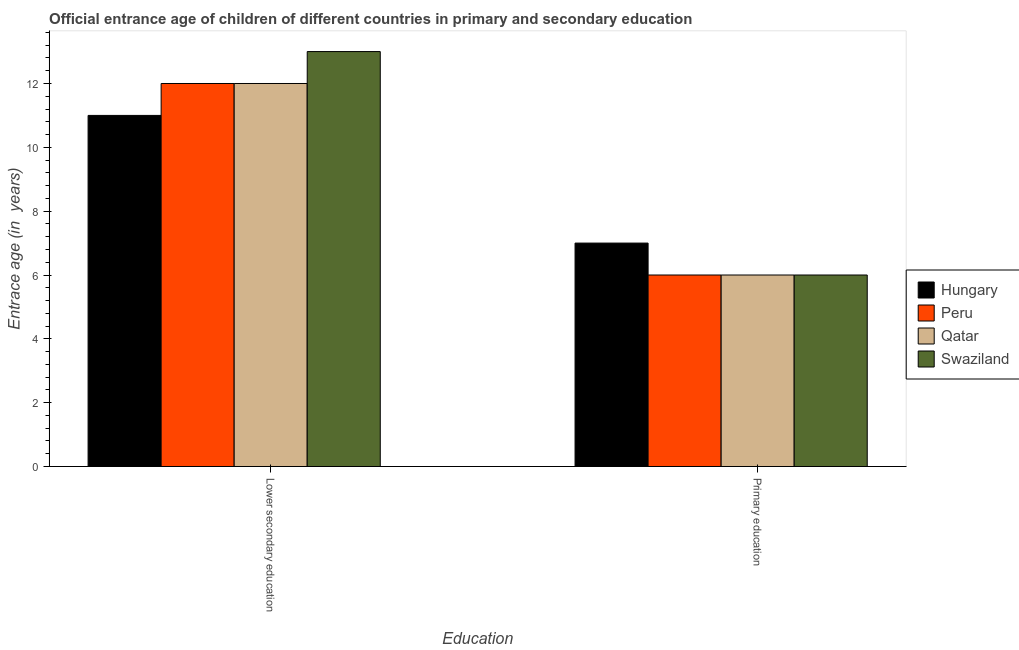How many bars are there on the 1st tick from the left?
Your response must be concise. 4. What is the label of the 2nd group of bars from the left?
Keep it short and to the point. Primary education. Across all countries, what is the maximum entrance age of children in lower secondary education?
Provide a succinct answer. 13. Across all countries, what is the minimum entrance age of children in lower secondary education?
Ensure brevity in your answer.  11. In which country was the entrance age of children in lower secondary education maximum?
Ensure brevity in your answer.  Swaziland. In which country was the entrance age of children in lower secondary education minimum?
Your answer should be compact. Hungary. What is the total entrance age of children in lower secondary education in the graph?
Provide a succinct answer. 48. What is the difference between the entrance age of children in lower secondary education in Qatar and the entrance age of chiildren in primary education in Peru?
Your answer should be compact. 6. What is the average entrance age of children in lower secondary education per country?
Make the answer very short. 12. What is the difference between the entrance age of chiildren in primary education and entrance age of children in lower secondary education in Swaziland?
Your answer should be very brief. -7. What is the ratio of the entrance age of chiildren in primary education in Hungary to that in Qatar?
Give a very brief answer. 1.17. Is the entrance age of children in lower secondary education in Peru less than that in Qatar?
Offer a very short reply. No. What does the 4th bar from the left in Lower secondary education represents?
Keep it short and to the point. Swaziland. What does the 4th bar from the right in Lower secondary education represents?
Your answer should be compact. Hungary. How many bars are there?
Your answer should be compact. 8. Are all the bars in the graph horizontal?
Make the answer very short. No. What is the difference between two consecutive major ticks on the Y-axis?
Make the answer very short. 2. Are the values on the major ticks of Y-axis written in scientific E-notation?
Make the answer very short. No. Does the graph contain grids?
Ensure brevity in your answer.  No. How are the legend labels stacked?
Provide a succinct answer. Vertical. What is the title of the graph?
Your answer should be compact. Official entrance age of children of different countries in primary and secondary education. What is the label or title of the X-axis?
Make the answer very short. Education. What is the label or title of the Y-axis?
Offer a terse response. Entrace age (in  years). What is the Entrace age (in  years) in Peru in Primary education?
Offer a very short reply. 6. What is the Entrace age (in  years) of Swaziland in Primary education?
Make the answer very short. 6. Across all Education, what is the maximum Entrace age (in  years) in Swaziland?
Give a very brief answer. 13. Across all Education, what is the minimum Entrace age (in  years) of Hungary?
Your response must be concise. 7. Across all Education, what is the minimum Entrace age (in  years) of Peru?
Ensure brevity in your answer.  6. What is the total Entrace age (in  years) in Hungary in the graph?
Make the answer very short. 18. What is the total Entrace age (in  years) in Peru in the graph?
Keep it short and to the point. 18. What is the total Entrace age (in  years) in Qatar in the graph?
Offer a very short reply. 18. What is the total Entrace age (in  years) of Swaziland in the graph?
Make the answer very short. 19. What is the difference between the Entrace age (in  years) of Hungary in Lower secondary education and that in Primary education?
Offer a very short reply. 4. What is the difference between the Entrace age (in  years) of Swaziland in Lower secondary education and that in Primary education?
Offer a very short reply. 7. What is the difference between the Entrace age (in  years) of Hungary in Lower secondary education and the Entrace age (in  years) of Swaziland in Primary education?
Your response must be concise. 5. What is the difference between the Entrace age (in  years) of Peru in Lower secondary education and the Entrace age (in  years) of Qatar in Primary education?
Give a very brief answer. 6. What is the difference between the Entrace age (in  years) in Peru in Lower secondary education and the Entrace age (in  years) in Swaziland in Primary education?
Your answer should be compact. 6. What is the average Entrace age (in  years) in Hungary per Education?
Your response must be concise. 9. What is the average Entrace age (in  years) in Peru per Education?
Give a very brief answer. 9. What is the difference between the Entrace age (in  years) of Hungary and Entrace age (in  years) of Peru in Lower secondary education?
Provide a succinct answer. -1. What is the difference between the Entrace age (in  years) of Hungary and Entrace age (in  years) of Swaziland in Lower secondary education?
Offer a terse response. -2. What is the difference between the Entrace age (in  years) in Peru and Entrace age (in  years) in Swaziland in Lower secondary education?
Offer a very short reply. -1. What is the difference between the Entrace age (in  years) in Qatar and Entrace age (in  years) in Swaziland in Lower secondary education?
Keep it short and to the point. -1. What is the difference between the Entrace age (in  years) of Hungary and Entrace age (in  years) of Peru in Primary education?
Offer a terse response. 1. What is the difference between the Entrace age (in  years) of Hungary and Entrace age (in  years) of Swaziland in Primary education?
Provide a succinct answer. 1. What is the difference between the Entrace age (in  years) in Peru and Entrace age (in  years) in Qatar in Primary education?
Ensure brevity in your answer.  0. What is the difference between the Entrace age (in  years) in Qatar and Entrace age (in  years) in Swaziland in Primary education?
Offer a very short reply. 0. What is the ratio of the Entrace age (in  years) of Hungary in Lower secondary education to that in Primary education?
Give a very brief answer. 1.57. What is the ratio of the Entrace age (in  years) of Peru in Lower secondary education to that in Primary education?
Make the answer very short. 2. What is the ratio of the Entrace age (in  years) of Swaziland in Lower secondary education to that in Primary education?
Provide a short and direct response. 2.17. What is the difference between the highest and the second highest Entrace age (in  years) in Qatar?
Offer a terse response. 6. What is the difference between the highest and the lowest Entrace age (in  years) in Peru?
Make the answer very short. 6. 